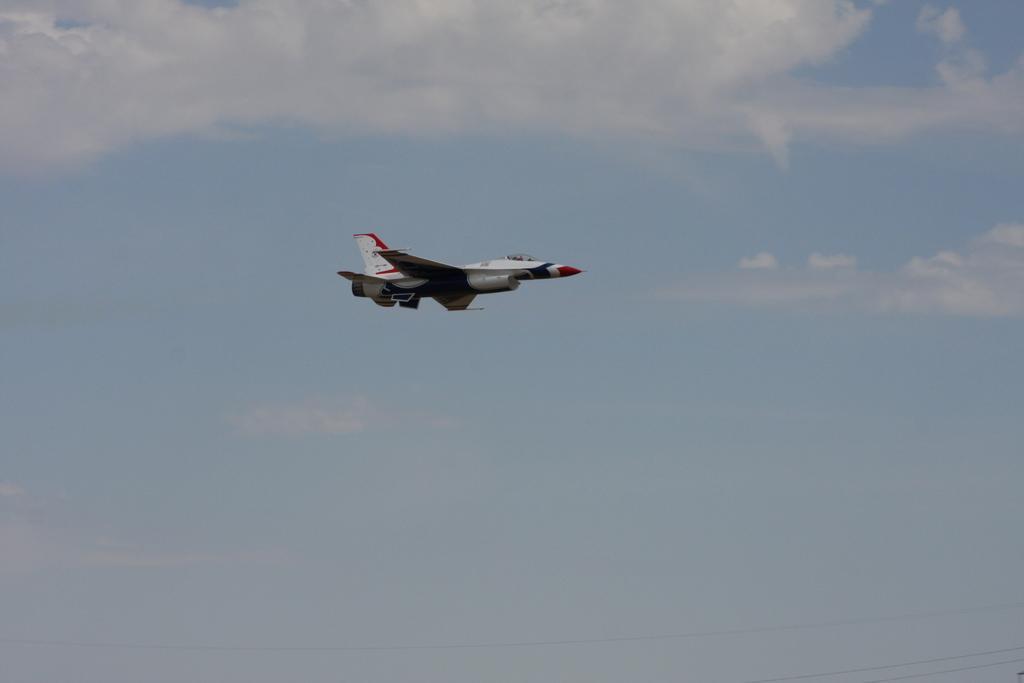Can you describe this image briefly? In the center of the image there is an aeroplane flying in the air. In the background we can see sky and clouds. 